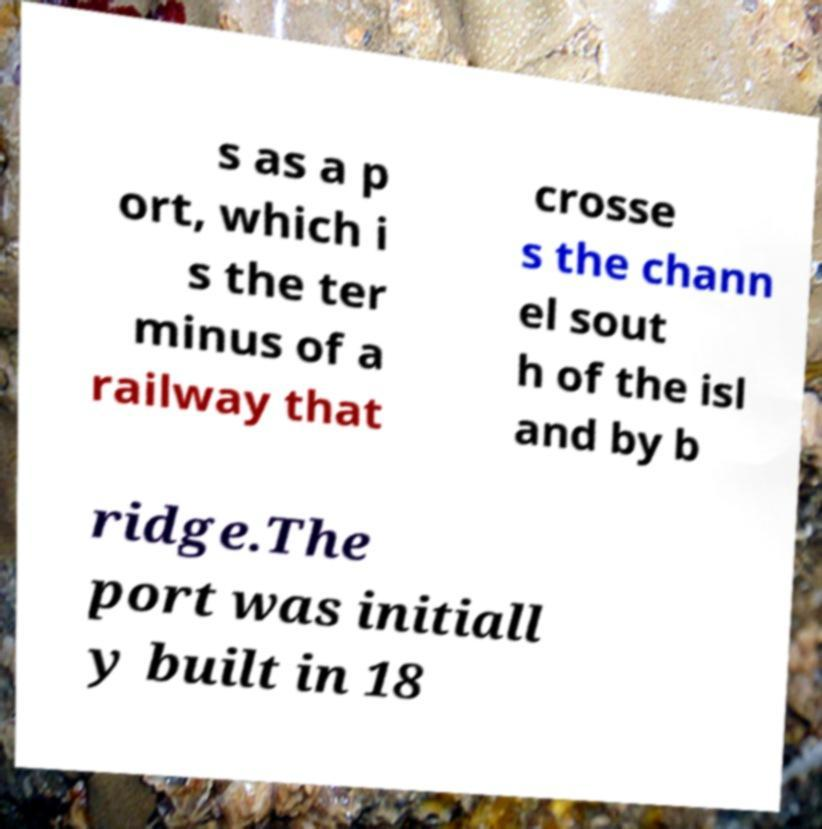Please identify and transcribe the text found in this image. s as a p ort, which i s the ter minus of a railway that crosse s the chann el sout h of the isl and by b ridge.The port was initiall y built in 18 